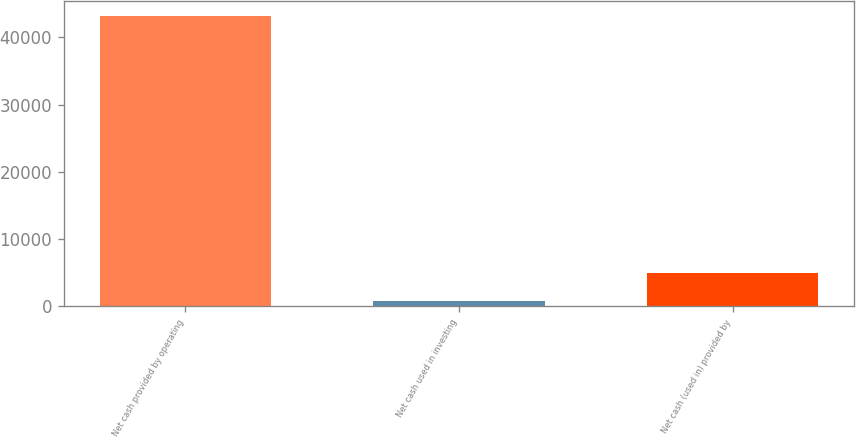<chart> <loc_0><loc_0><loc_500><loc_500><bar_chart><fcel>Net cash provided by operating<fcel>Net cash used in investing<fcel>Net cash (used in) provided by<nl><fcel>43229<fcel>711<fcel>4962.8<nl></chart> 